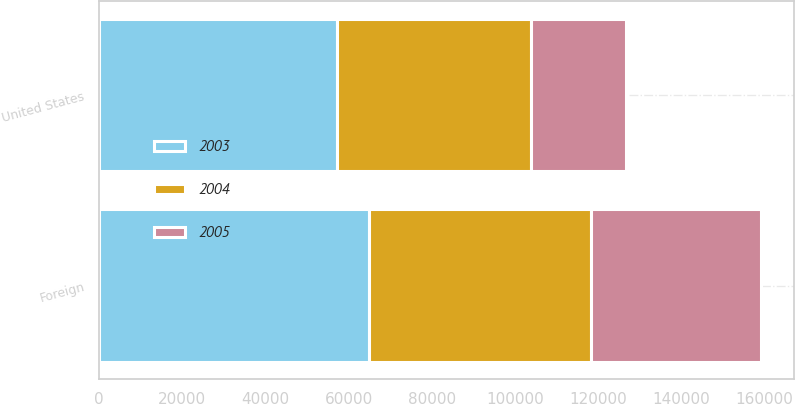Convert chart to OTSL. <chart><loc_0><loc_0><loc_500><loc_500><stacked_bar_chart><ecel><fcel>United States<fcel>Foreign<nl><fcel>2003<fcel>57335<fcel>64889<nl><fcel>2004<fcel>46512<fcel>53397<nl><fcel>2005<fcel>22984<fcel>40864<nl></chart> 